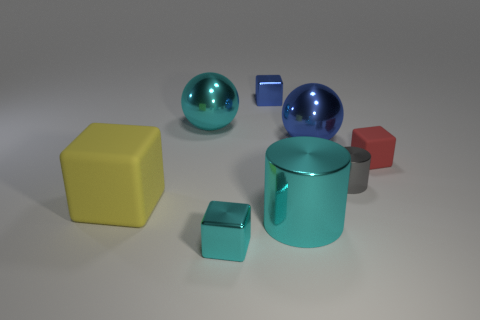How many big cyan cylinders are left of the cube in front of the big yellow cube?
Keep it short and to the point. 0. The big object that is to the left of the small cyan object and in front of the small gray object has what shape?
Offer a terse response. Cube. How many small shiny objects are the same color as the big metallic cylinder?
Your response must be concise. 1. Is there a shiny block to the left of the block in front of the large metallic thing that is in front of the large blue thing?
Make the answer very short. No. There is a block that is both left of the tiny red matte block and right of the tiny cyan shiny thing; what is its size?
Ensure brevity in your answer.  Small. How many big cubes are the same material as the gray cylinder?
Give a very brief answer. 0. What number of spheres are either large yellow rubber objects or large blue objects?
Your response must be concise. 1. What size is the rubber block on the left side of the gray cylinder that is to the right of the large cyan metallic thing in front of the large blue metal sphere?
Your answer should be very brief. Large. The metal thing that is on the right side of the small cyan block and in front of the yellow rubber block is what color?
Offer a very short reply. Cyan. There is a gray cylinder; is its size the same as the shiny block behind the cyan cube?
Make the answer very short. Yes. 